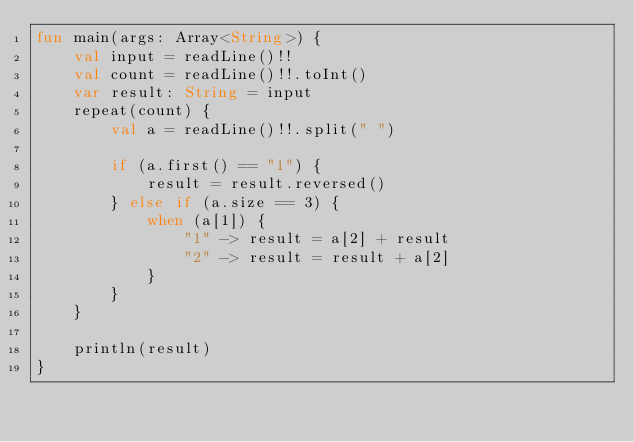Convert code to text. <code><loc_0><loc_0><loc_500><loc_500><_Kotlin_>fun main(args: Array<String>) {
    val input = readLine()!!
    val count = readLine()!!.toInt()
    var result: String = input
    repeat(count) {
        val a = readLine()!!.split(" ")

        if (a.first() == "1") {
            result = result.reversed()
        } else if (a.size == 3) {
            when (a[1]) {
                "1" -> result = a[2] + result
                "2" -> result = result + a[2]
            }
        }
    }

    println(result)
}</code> 